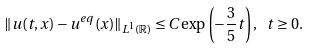Convert formula to latex. <formula><loc_0><loc_0><loc_500><loc_500>\| u ( t , x ) - u ^ { e q } ( x ) \| _ { L ^ { 1 } ( \mathbb { R } ) } \leq C \exp \left ( - \frac { 3 } { 5 } t \right ) , \, \ t \geq 0 .</formula> 